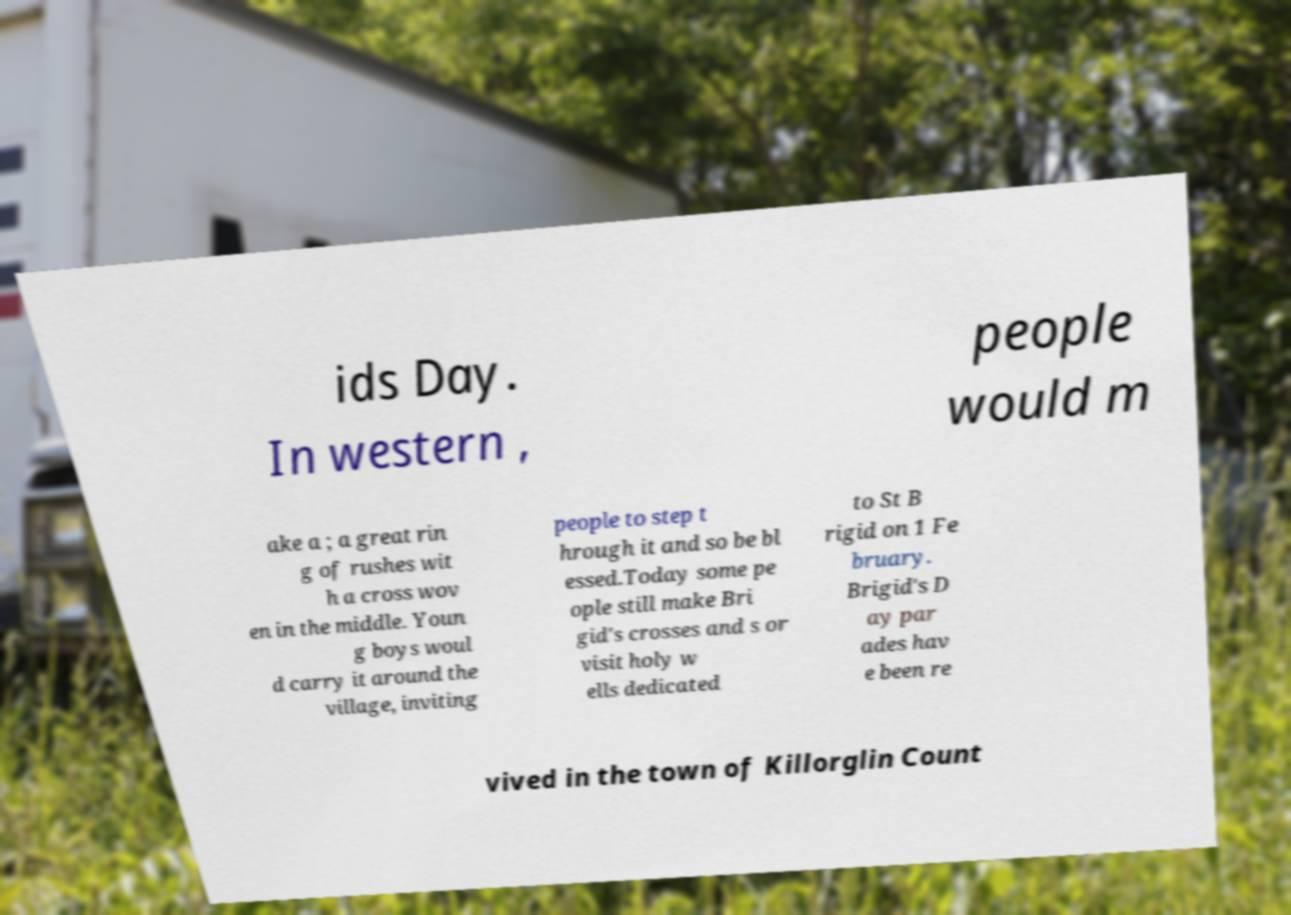Please read and relay the text visible in this image. What does it say? ids Day. In western , people would m ake a ; a great rin g of rushes wit h a cross wov en in the middle. Youn g boys woul d carry it around the village, inviting people to step t hrough it and so be bl essed.Today some pe ople still make Bri gid's crosses and s or visit holy w ells dedicated to St B rigid on 1 Fe bruary. Brigid's D ay par ades hav e been re vived in the town of Killorglin Count 